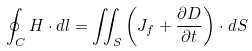<formula> <loc_0><loc_0><loc_500><loc_500>\oint _ { C } H \cdot d { l } = \iint _ { S } \left ( J _ { f } + { \frac { \partial D } { \partial t } } \right ) \cdot d S</formula> 